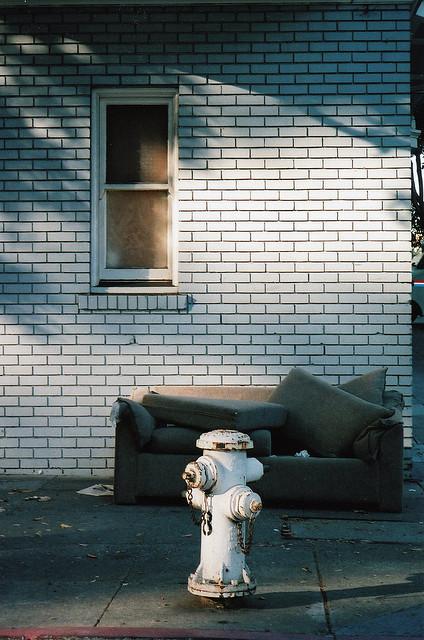What color is the couch?
Short answer required. Brown. What is the building made out of?
Keep it brief. Brick. What is the color of the hydrant?
Concise answer only. White. 